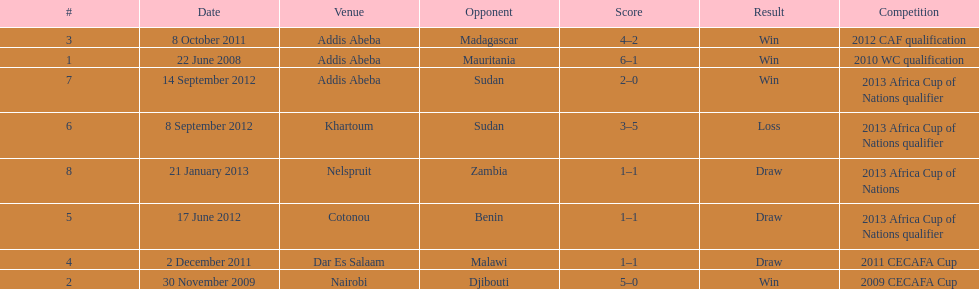What date gives was their only loss? 8 September 2012. 